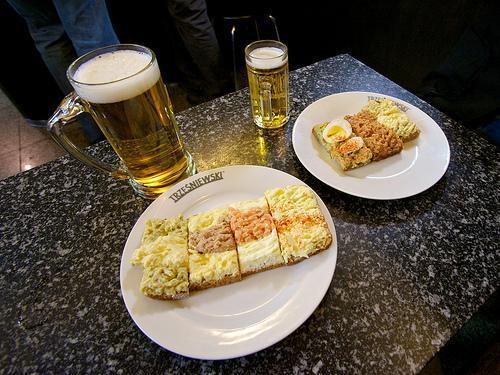How many plates?
Give a very brief answer. 2. 